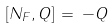Convert formula to latex. <formula><loc_0><loc_0><loc_500><loc_500>[ N _ { F } , Q ] \, = \, - Q</formula> 